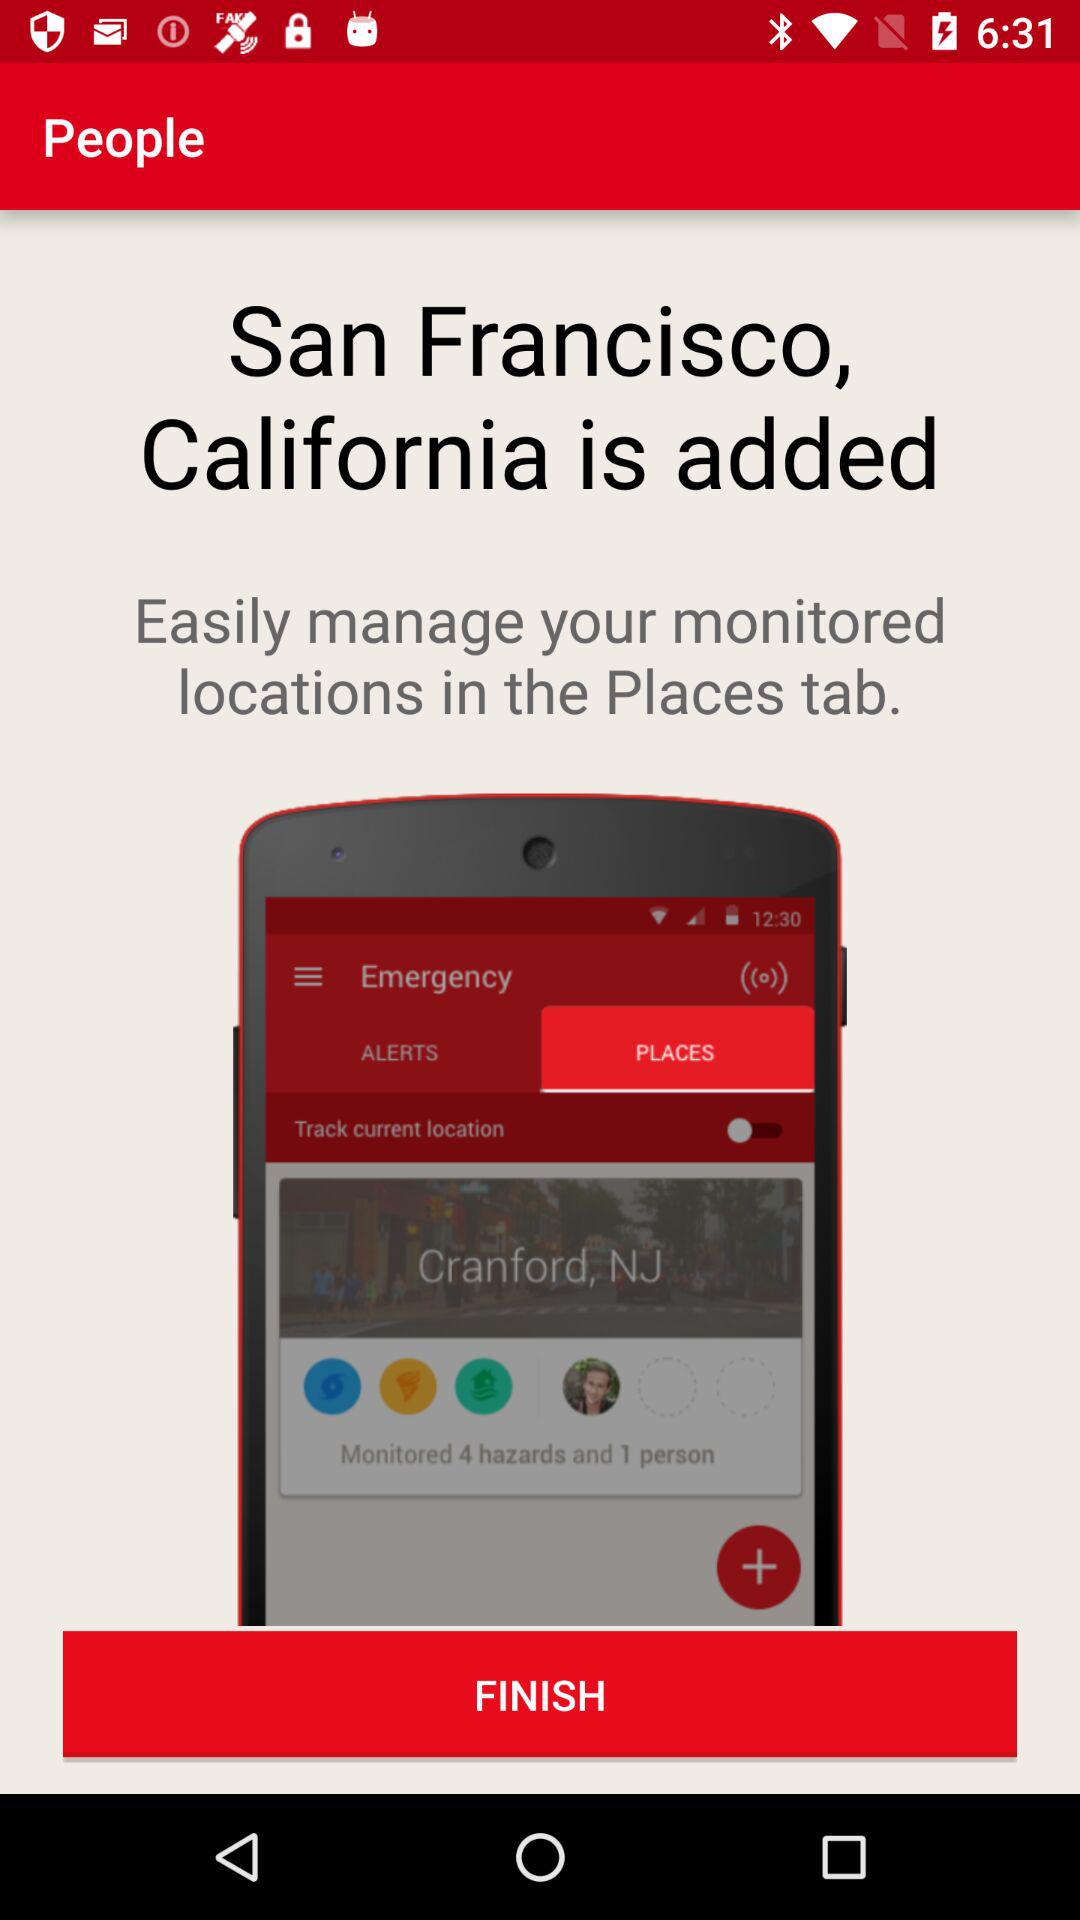What state is mentioned? The mentioned state is California. 